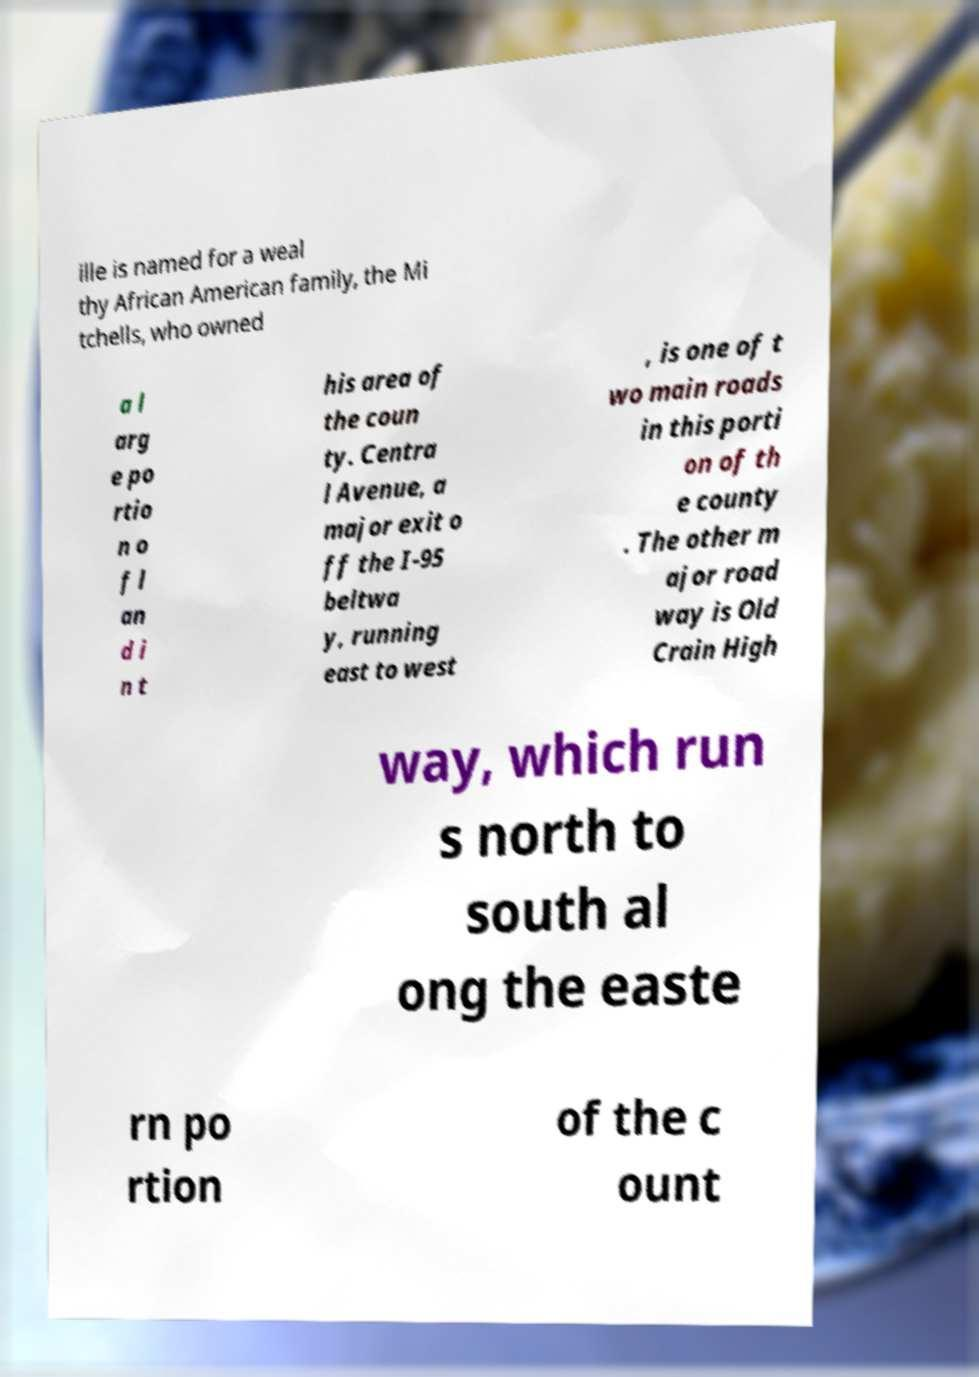Please read and relay the text visible in this image. What does it say? ille is named for a weal thy African American family, the Mi tchells, who owned a l arg e po rtio n o f l an d i n t his area of the coun ty. Centra l Avenue, a major exit o ff the I-95 beltwa y, running east to west , is one of t wo main roads in this porti on of th e county . The other m ajor road way is Old Crain High way, which run s north to south al ong the easte rn po rtion of the c ount 